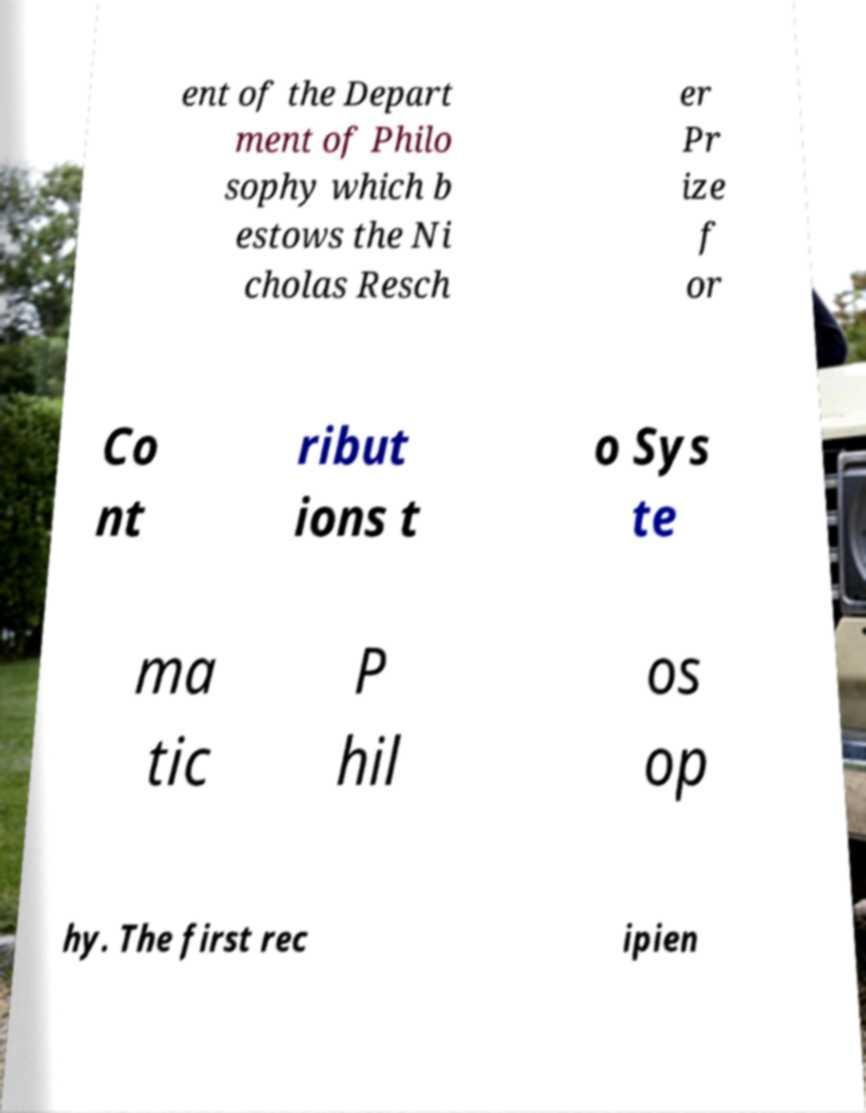What messages or text are displayed in this image? I need them in a readable, typed format. ent of the Depart ment of Philo sophy which b estows the Ni cholas Resch er Pr ize f or Co nt ribut ions t o Sys te ma tic P hil os op hy. The first rec ipien 